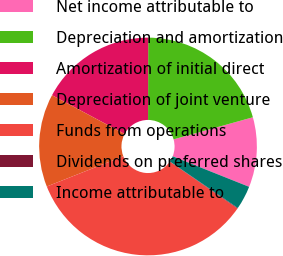<chart> <loc_0><loc_0><loc_500><loc_500><pie_chart><fcel>Net income attributable to<fcel>Depreciation and amortization<fcel>Amortization of initial direct<fcel>Depreciation of joint venture<fcel>Funds from operations<fcel>Dividends on preferred shares<fcel>Income attributable to<nl><fcel>10.37%<fcel>20.65%<fcel>17.22%<fcel>13.8%<fcel>34.36%<fcel>0.09%<fcel>3.52%<nl></chart> 